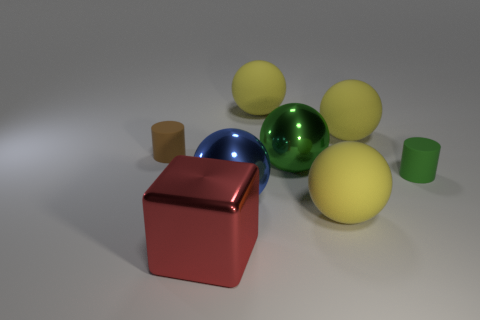What number of yellow things are made of the same material as the large red block?
Provide a short and direct response. 0. Is the number of cubes greater than the number of small things?
Ensure brevity in your answer.  No. How many large rubber things are right of the cylinder that is left of the small green thing?
Your answer should be very brief. 3. What number of objects are rubber things on the left side of the blue metallic thing or cylinders?
Your answer should be compact. 2. Is there a tiny green rubber thing of the same shape as the big green object?
Provide a succinct answer. No. The yellow matte object that is in front of the cylinder right of the brown thing is what shape?
Your answer should be very brief. Sphere. How many spheres are small brown rubber objects or yellow rubber things?
Keep it short and to the point. 3. There is a big rubber object that is to the left of the big green shiny ball; is its shape the same as the small thing that is on the right side of the red shiny thing?
Offer a terse response. No. What is the color of the big thing that is both in front of the big blue ball and on the right side of the large green sphere?
Your response must be concise. Yellow. Is the color of the metallic cube the same as the small object that is in front of the tiny brown matte cylinder?
Give a very brief answer. No. 